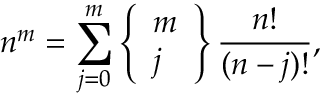<formula> <loc_0><loc_0><loc_500><loc_500>n ^ { m } = \sum _ { j = 0 } ^ { m } \left \{ { \begin{array} { l } { m } \\ { j } \end{array} } \right \} { \frac { n ! } { ( n - j ) ! } } ,</formula> 